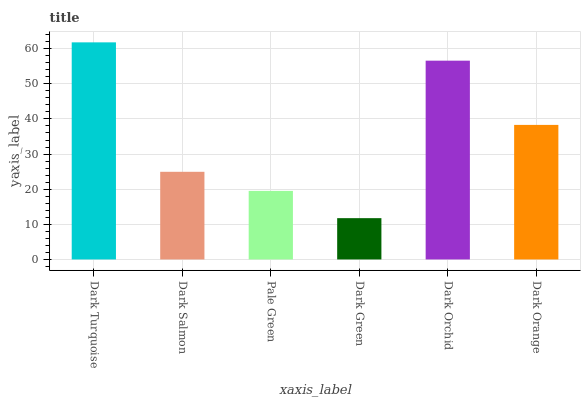Is Dark Salmon the minimum?
Answer yes or no. No. Is Dark Salmon the maximum?
Answer yes or no. No. Is Dark Turquoise greater than Dark Salmon?
Answer yes or no. Yes. Is Dark Salmon less than Dark Turquoise?
Answer yes or no. Yes. Is Dark Salmon greater than Dark Turquoise?
Answer yes or no. No. Is Dark Turquoise less than Dark Salmon?
Answer yes or no. No. Is Dark Orange the high median?
Answer yes or no. Yes. Is Dark Salmon the low median?
Answer yes or no. Yes. Is Pale Green the high median?
Answer yes or no. No. Is Pale Green the low median?
Answer yes or no. No. 